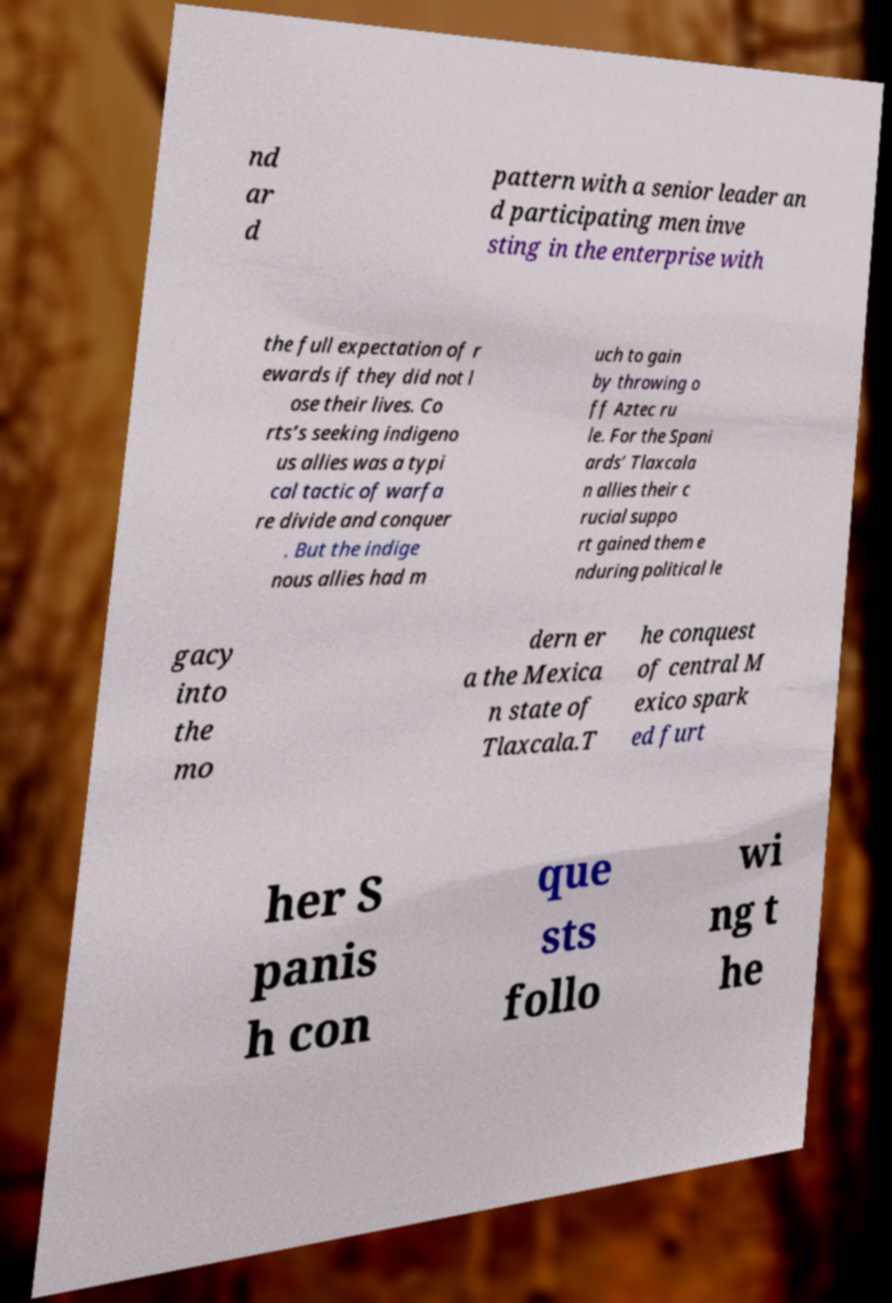Can you read and provide the text displayed in the image?This photo seems to have some interesting text. Can you extract and type it out for me? nd ar d pattern with a senior leader an d participating men inve sting in the enterprise with the full expectation of r ewards if they did not l ose their lives. Co rts’s seeking indigeno us allies was a typi cal tactic of warfa re divide and conquer . But the indige nous allies had m uch to gain by throwing o ff Aztec ru le. For the Spani ards’ Tlaxcala n allies their c rucial suppo rt gained them e nduring political le gacy into the mo dern er a the Mexica n state of Tlaxcala.T he conquest of central M exico spark ed furt her S panis h con que sts follo wi ng t he 